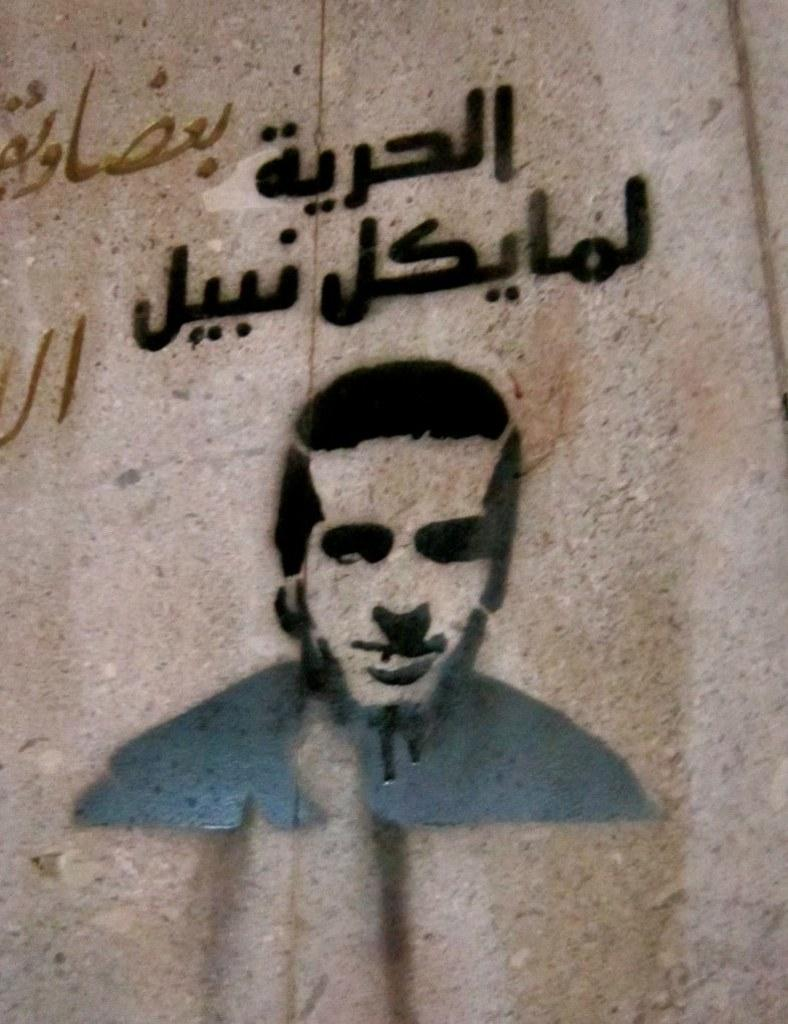What is depicted on the wall in the image? There is a painting of a person on the wall. What else can be seen in the image besides the painting? There is some text in the image. Can you see any nails or snails in the image? No, there are no nails or snails present in the image. What type of tool is being used by the person in the painting? The painting is a static image, so it does not show any tools being used by the person. 